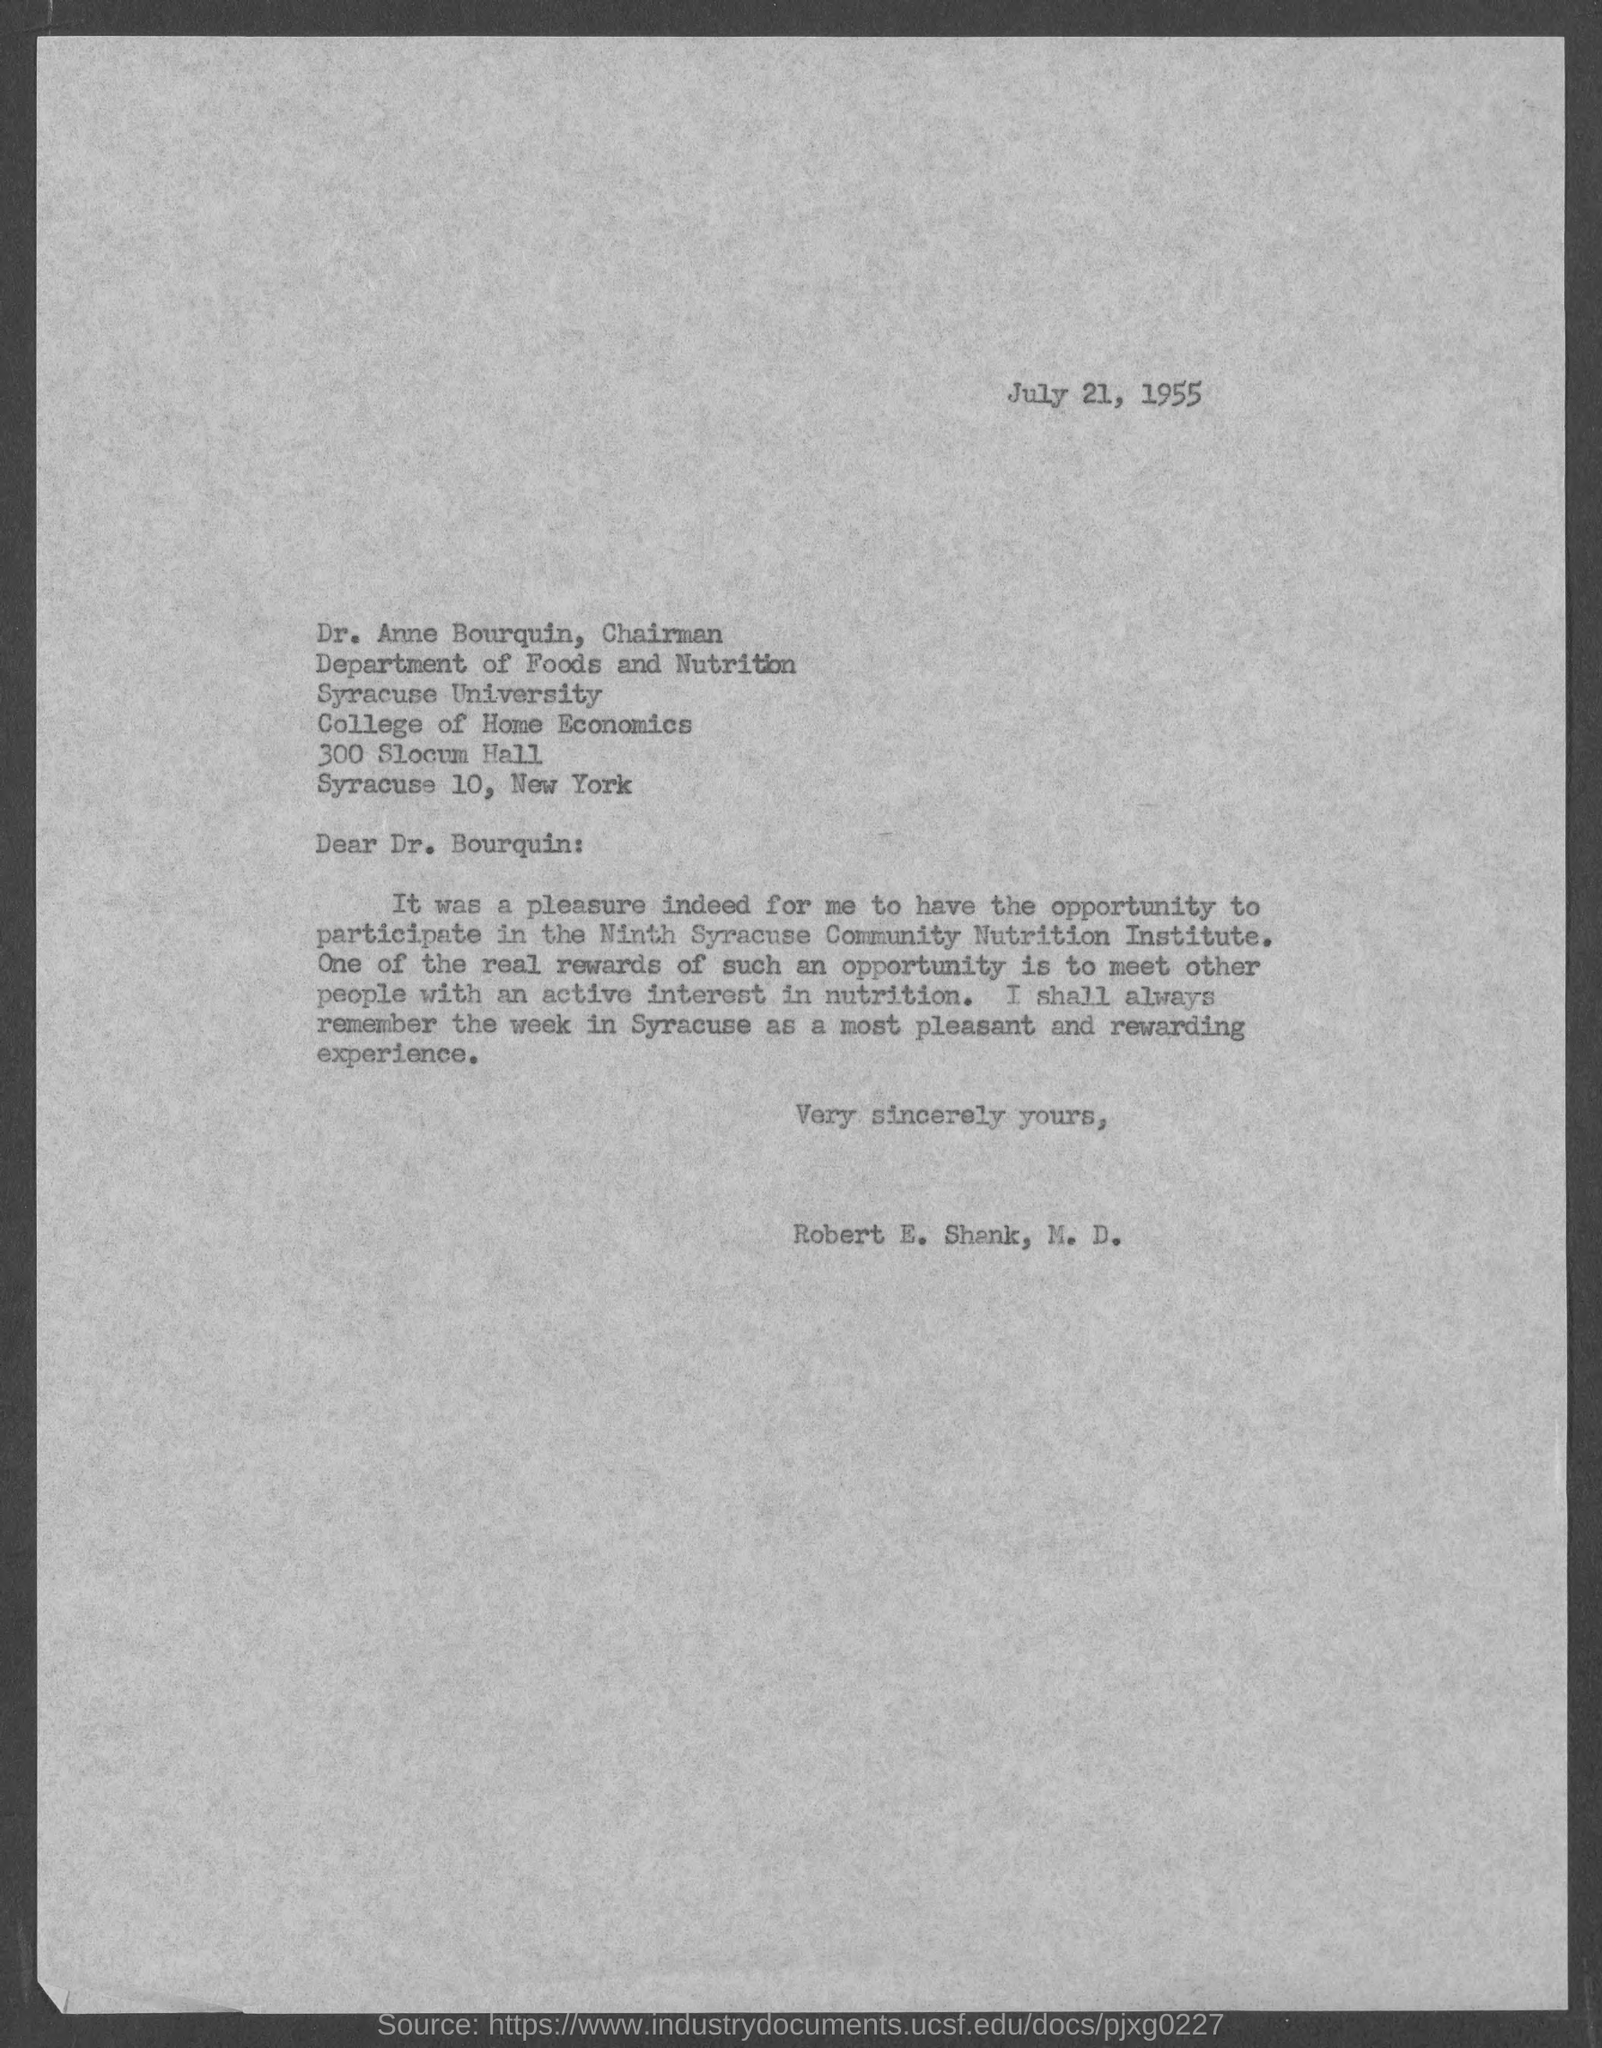What is the date?
Provide a short and direct response. July 21, 1955. What is the salutation of this letter?
Your response must be concise. Dear Dr. Bourquin:. 